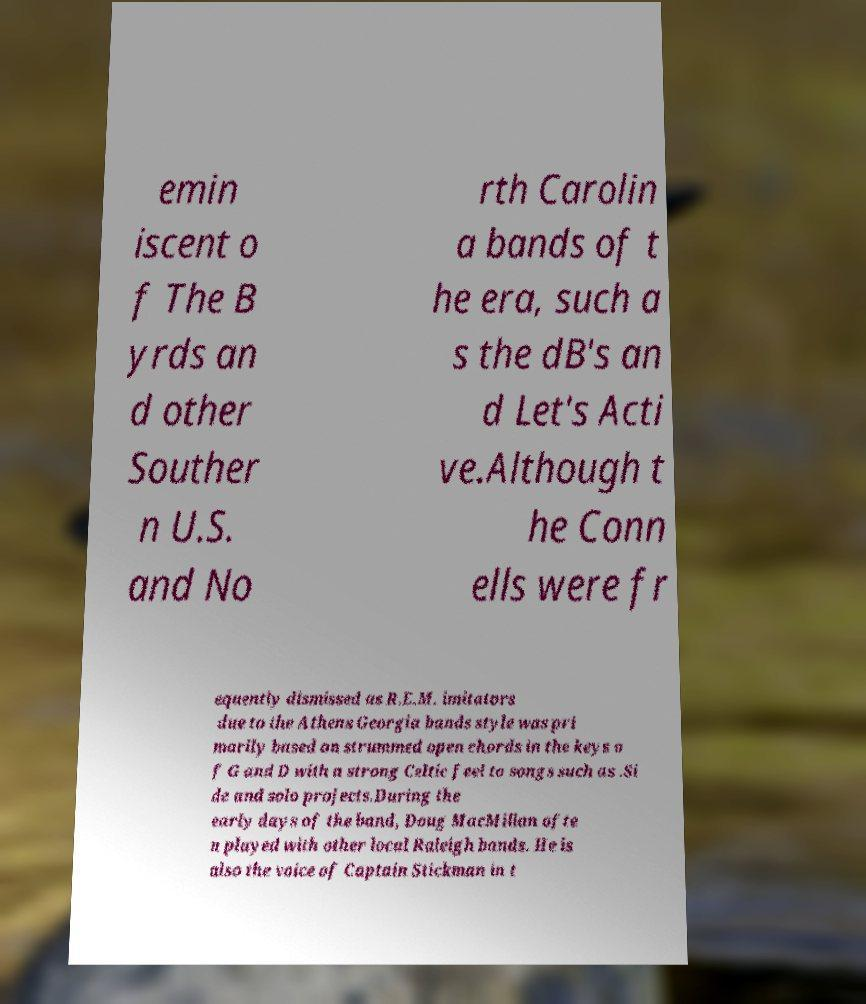Can you accurately transcribe the text from the provided image for me? emin iscent o f The B yrds an d other Souther n U.S. and No rth Carolin a bands of t he era, such a s the dB's an d Let's Acti ve.Although t he Conn ells were fr equently dismissed as R.E.M. imitators due to the Athens Georgia bands style was pri marily based on strummed open chords in the keys o f G and D with a strong Celtic feel to songs such as .Si de and solo projects.During the early days of the band, Doug MacMillan ofte n played with other local Raleigh bands. He is also the voice of Captain Stickman in t 